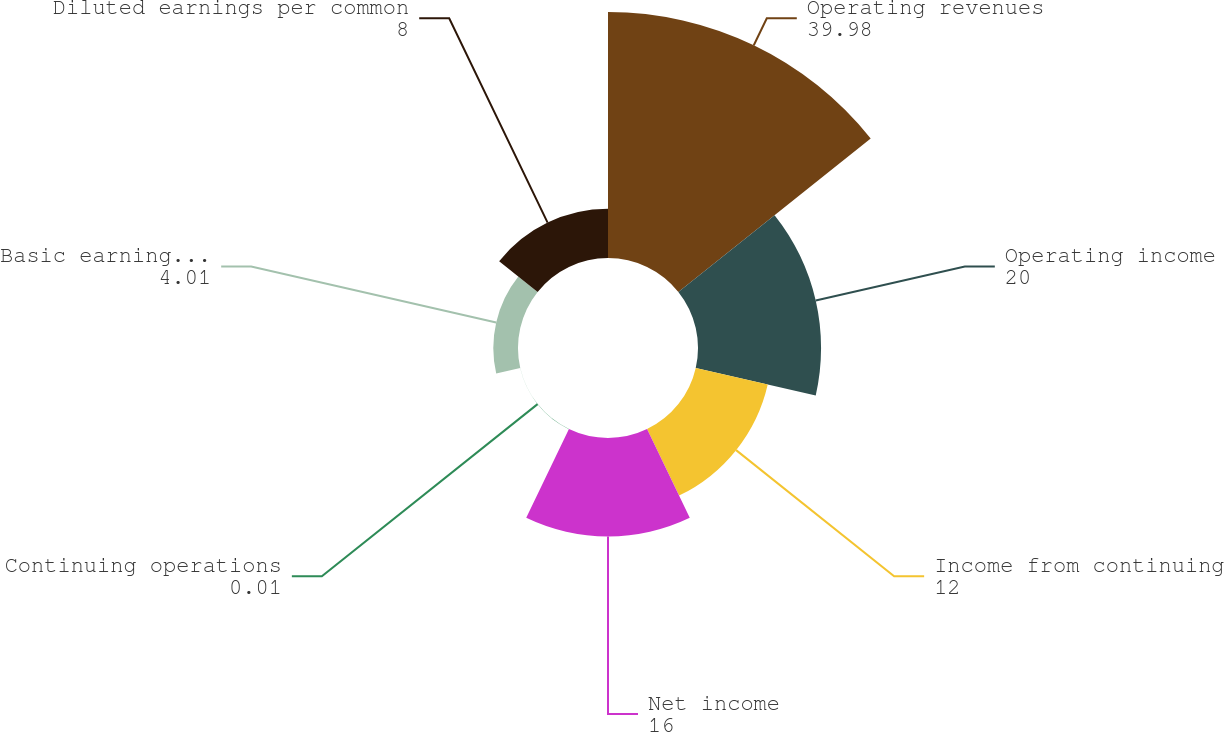Convert chart. <chart><loc_0><loc_0><loc_500><loc_500><pie_chart><fcel>Operating revenues<fcel>Operating income<fcel>Income from continuing<fcel>Net income<fcel>Continuing operations<fcel>Basic earnings per common<fcel>Diluted earnings per common<nl><fcel>39.98%<fcel>20.0%<fcel>12.0%<fcel>16.0%<fcel>0.01%<fcel>4.01%<fcel>8.0%<nl></chart> 